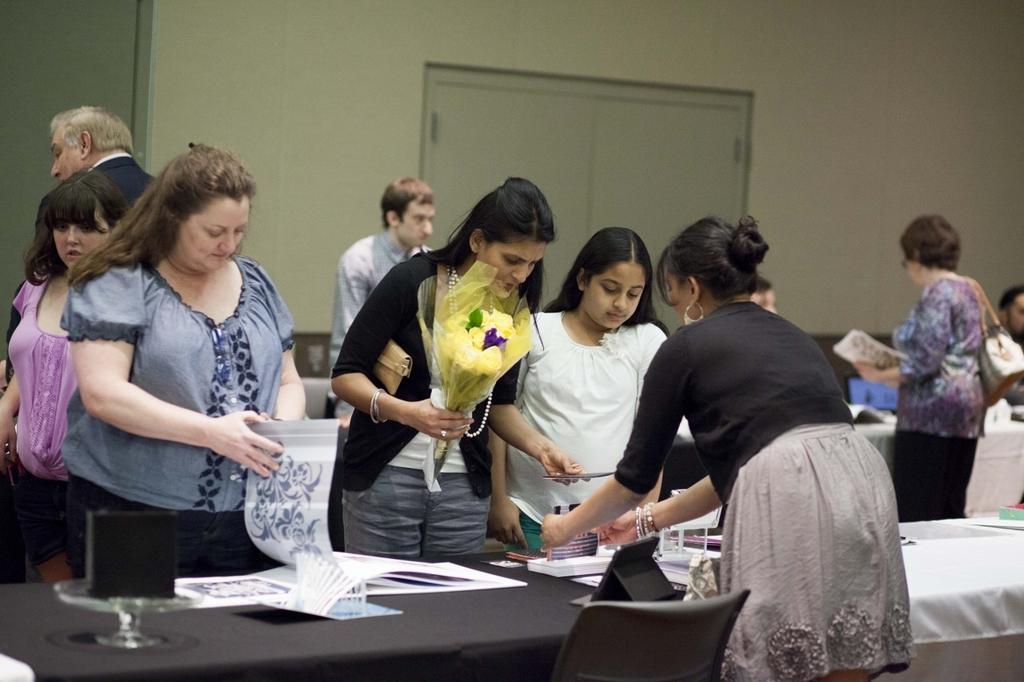Can you describe this image briefly? In this picture there is a lady at the right side of the image is showing a demo of things, there are some people those who are purchasing the things here in the area of the image, the lady who is standing at the center of the image is holding the flowers, there is a door at the center of the image behind the people. 